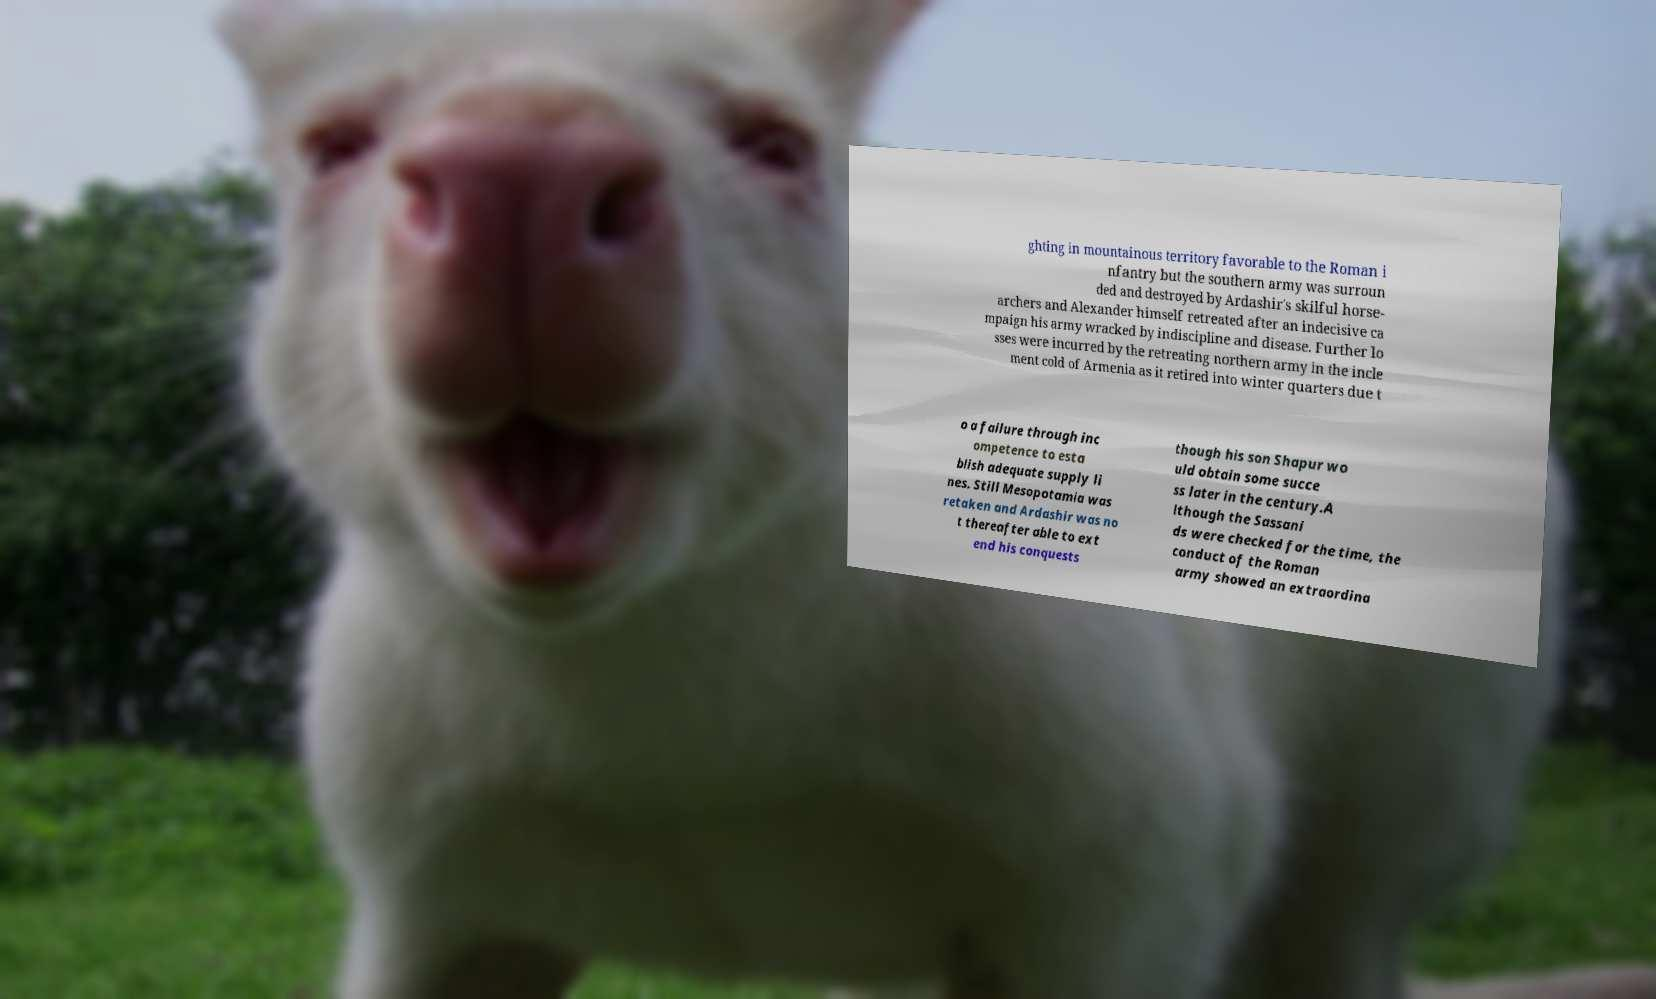I need the written content from this picture converted into text. Can you do that? ghting in mountainous territory favorable to the Roman i nfantry but the southern army was surroun ded and destroyed by Ardashir's skilful horse- archers and Alexander himself retreated after an indecisive ca mpaign his army wracked by indiscipline and disease. Further lo sses were incurred by the retreating northern army in the incle ment cold of Armenia as it retired into winter quarters due t o a failure through inc ompetence to esta blish adequate supply li nes. Still Mesopotamia was retaken and Ardashir was no t thereafter able to ext end his conquests though his son Shapur wo uld obtain some succe ss later in the century.A lthough the Sassani ds were checked for the time, the conduct of the Roman army showed an extraordina 